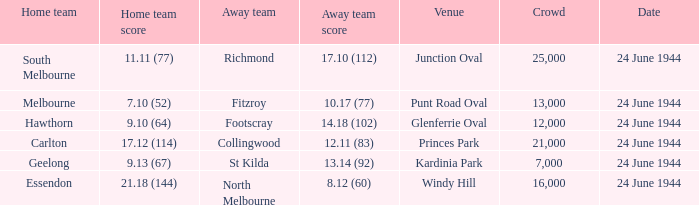When Essendon was the Home Team, what was the Away Team score? 8.12 (60). 